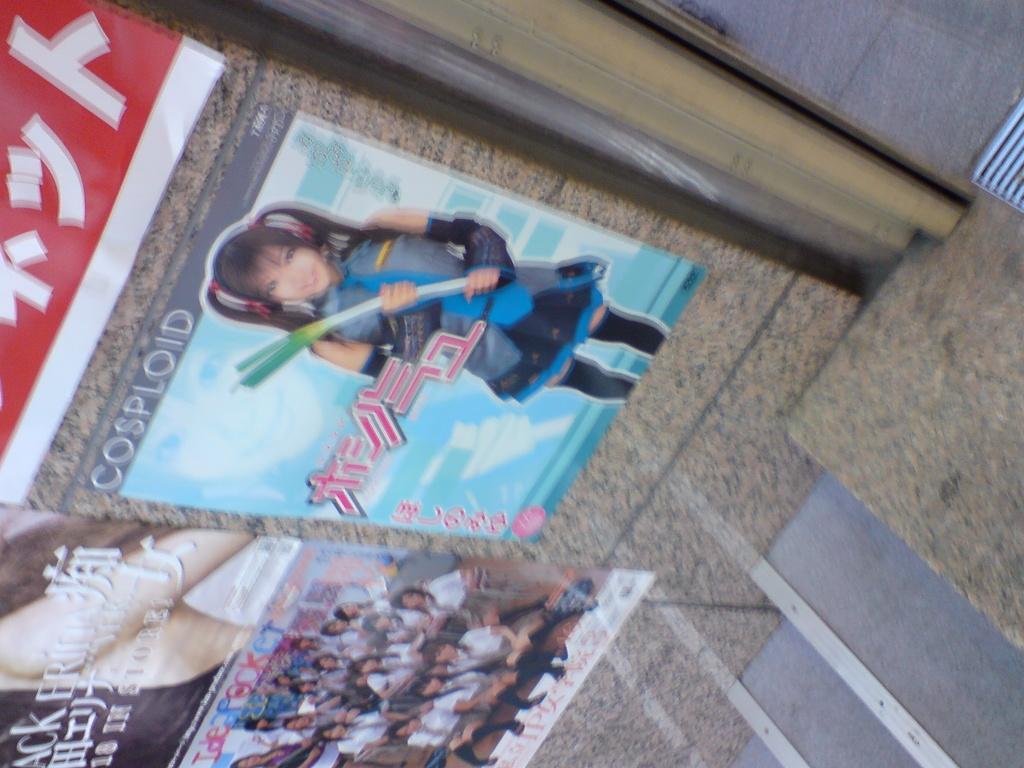Can you describe this image briefly? In this image, we can see posts on the wall. On the right side of the image, we can see stairs and floor. On these posters, we can see people and text. 